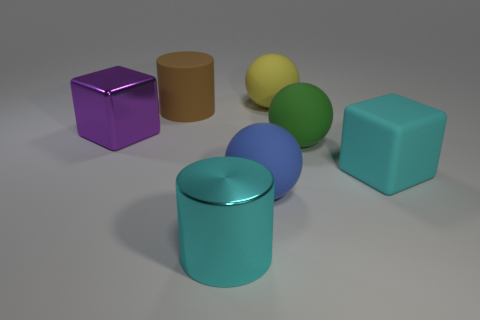There is a rubber cube; does it have the same size as the shiny thing that is left of the big cyan metallic cylinder?
Offer a very short reply. Yes. How many other objects are the same material as the purple block?
Offer a very short reply. 1. What number of objects are rubber balls that are behind the brown cylinder or objects that are to the right of the big brown object?
Keep it short and to the point. 5. What material is the green thing that is the same shape as the large yellow matte object?
Ensure brevity in your answer.  Rubber. Are there any big cyan metal cylinders?
Offer a very short reply. Yes. What is the size of the thing that is in front of the green sphere and to the right of the yellow rubber thing?
Your response must be concise. Large. The brown thing has what shape?
Keep it short and to the point. Cylinder. There is a cylinder behind the purple object; is there a big purple object on the right side of it?
Offer a terse response. No. What is the material of the green ball that is the same size as the blue matte ball?
Give a very brief answer. Rubber. Are there any purple metallic cubes of the same size as the cyan block?
Your answer should be compact. Yes. 